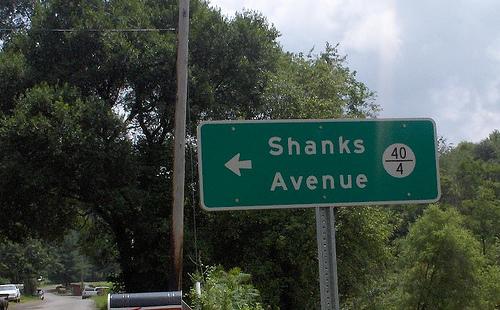Does this look like a well-developed neighborhood?
Concise answer only. No. What type of utility pole is pictured?
Short answer required. Electric. What shape is the sign?
Short answer required. Rectangle. How many street signs are there?
Write a very short answer. 1. What is the second letter of the word on this sign?
Quick response, please. H. Is the skate route to the right?
Quick response, please. No. How many street names have white in them?
Short answer required. 1. Who takes care of this street's upkeep?
Quick response, please. City. Do you really have to turn left to go to Shanks?
Write a very short answer. Yes. 